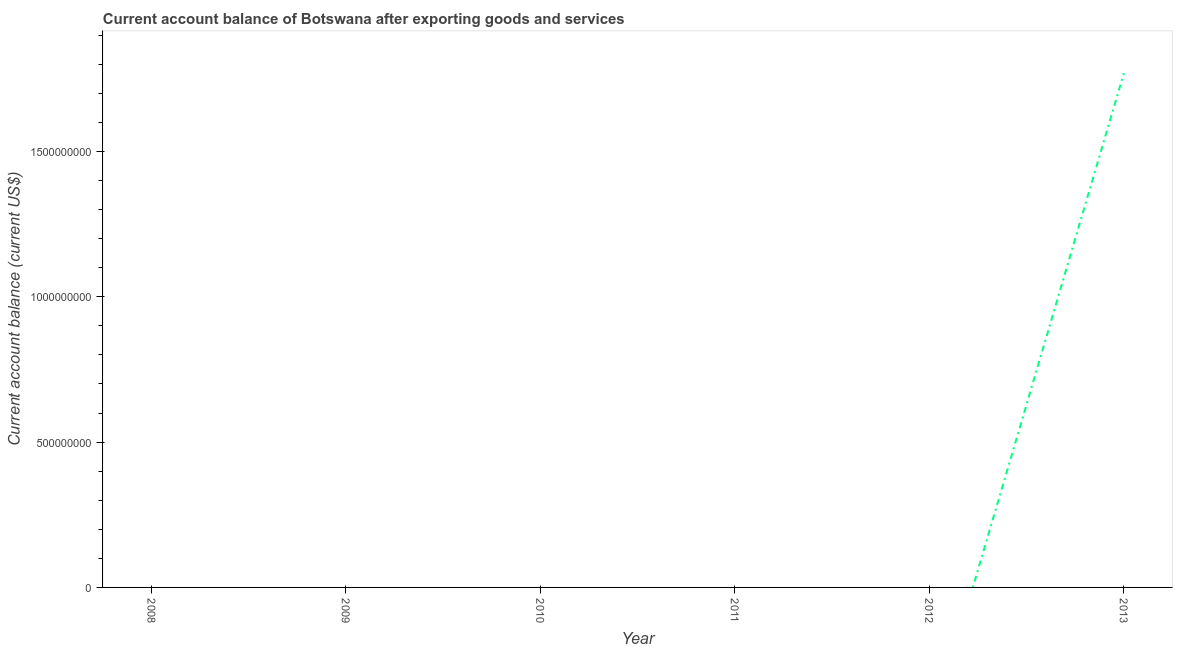Across all years, what is the maximum current account balance?
Your response must be concise. 1.77e+09. Across all years, what is the minimum current account balance?
Offer a very short reply. 0. In which year was the current account balance maximum?
Offer a very short reply. 2013. What is the sum of the current account balance?
Provide a succinct answer. 1.77e+09. What is the average current account balance per year?
Your response must be concise. 2.95e+08. What is the median current account balance?
Offer a very short reply. 0. In how many years, is the current account balance greater than 300000000 US$?
Offer a very short reply. 1. What is the difference between the highest and the lowest current account balance?
Make the answer very short. 1.77e+09. How many years are there in the graph?
Offer a terse response. 6. What is the difference between two consecutive major ticks on the Y-axis?
Make the answer very short. 5.00e+08. Does the graph contain grids?
Offer a very short reply. No. What is the title of the graph?
Provide a short and direct response. Current account balance of Botswana after exporting goods and services. What is the label or title of the X-axis?
Keep it short and to the point. Year. What is the label or title of the Y-axis?
Provide a succinct answer. Current account balance (current US$). What is the Current account balance (current US$) in 2008?
Offer a very short reply. 0. What is the Current account balance (current US$) of 2013?
Your answer should be very brief. 1.77e+09. 